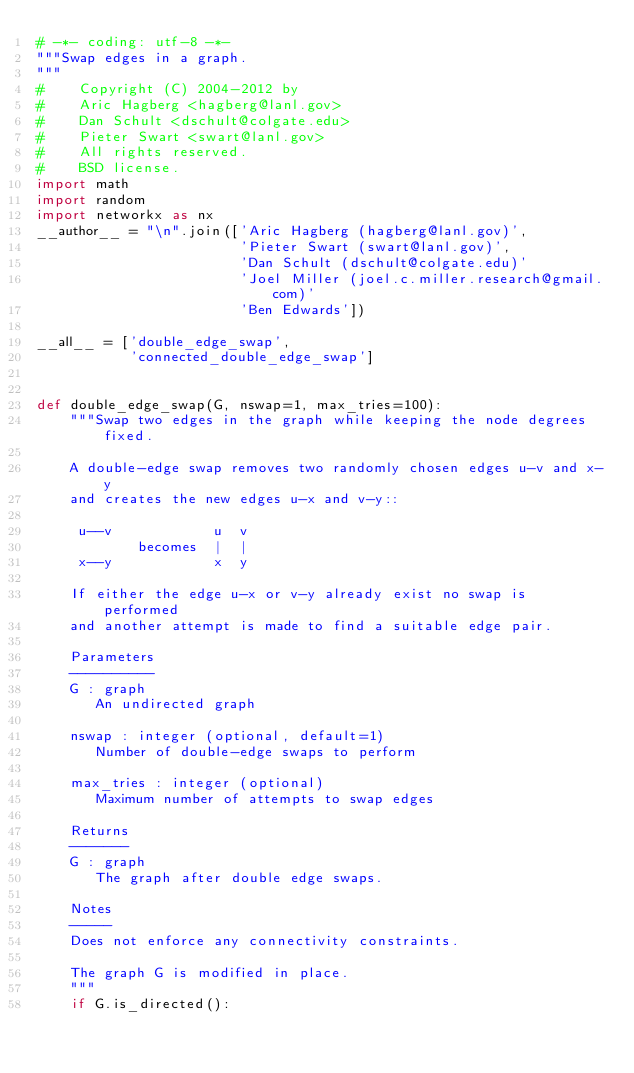<code> <loc_0><loc_0><loc_500><loc_500><_Python_># -*- coding: utf-8 -*-
"""Swap edges in a graph.
"""
#    Copyright (C) 2004-2012 by
#    Aric Hagberg <hagberg@lanl.gov>
#    Dan Schult <dschult@colgate.edu>
#    Pieter Swart <swart@lanl.gov>
#    All rights reserved.
#    BSD license.
import math
import random
import networkx as nx
__author__ = "\n".join(['Aric Hagberg (hagberg@lanl.gov)',
                        'Pieter Swart (swart@lanl.gov)',
                        'Dan Schult (dschult@colgate.edu)'
                        'Joel Miller (joel.c.miller.research@gmail.com)'
                        'Ben Edwards'])

__all__ = ['double_edge_swap',
           'connected_double_edge_swap']


def double_edge_swap(G, nswap=1, max_tries=100):
    """Swap two edges in the graph while keeping the node degrees fixed.

    A double-edge swap removes two randomly chosen edges u-v and x-y
    and creates the new edges u-x and v-y::

     u--v            u  v
            becomes  |  |
     x--y            x  y

    If either the edge u-x or v-y already exist no swap is performed
    and another attempt is made to find a suitable edge pair.

    Parameters
    ----------
    G : graph
       An undirected graph

    nswap : integer (optional, default=1)
       Number of double-edge swaps to perform

    max_tries : integer (optional)
       Maximum number of attempts to swap edges

    Returns
    -------
    G : graph
       The graph after double edge swaps.

    Notes
    -----
    Does not enforce any connectivity constraints.

    The graph G is modified in place.
    """
    if G.is_directed():</code> 